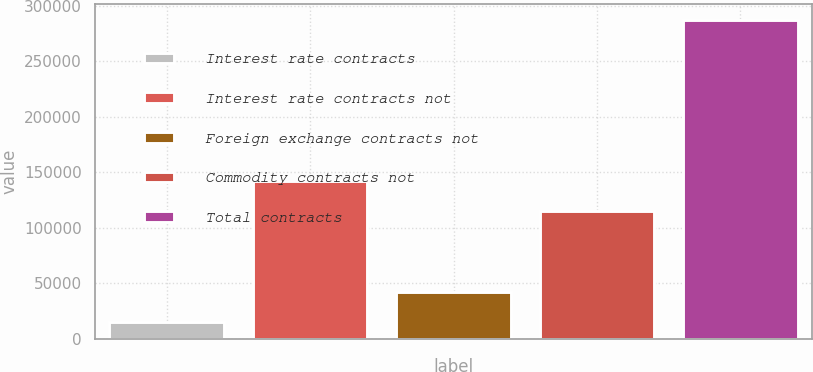Convert chart to OTSL. <chart><loc_0><loc_0><loc_500><loc_500><bar_chart><fcel>Interest rate contracts<fcel>Interest rate contracts not<fcel>Foreign exchange contracts not<fcel>Commodity contracts not<fcel>Total contracts<nl><fcel>15215<fcel>142086<fcel>42413.5<fcel>114887<fcel>287200<nl></chart> 